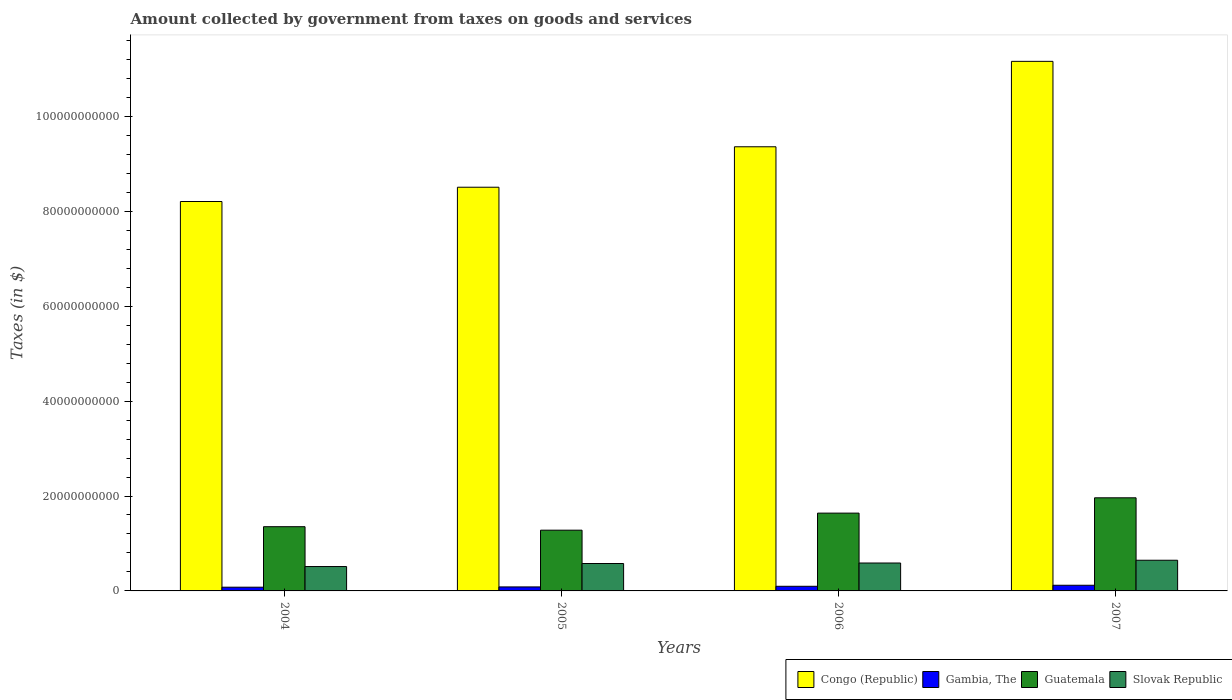How many different coloured bars are there?
Offer a very short reply. 4. Are the number of bars on each tick of the X-axis equal?
Give a very brief answer. Yes. How many bars are there on the 2nd tick from the left?
Your answer should be compact. 4. In how many cases, is the number of bars for a given year not equal to the number of legend labels?
Offer a very short reply. 0. What is the amount collected by government from taxes on goods and services in Slovak Republic in 2005?
Keep it short and to the point. 5.78e+09. Across all years, what is the maximum amount collected by government from taxes on goods and services in Slovak Republic?
Your answer should be very brief. 6.47e+09. Across all years, what is the minimum amount collected by government from taxes on goods and services in Slovak Republic?
Offer a terse response. 5.14e+09. In which year was the amount collected by government from taxes on goods and services in Slovak Republic maximum?
Make the answer very short. 2007. In which year was the amount collected by government from taxes on goods and services in Guatemala minimum?
Keep it short and to the point. 2005. What is the total amount collected by government from taxes on goods and services in Guatemala in the graph?
Provide a succinct answer. 6.24e+1. What is the difference between the amount collected by government from taxes on goods and services in Slovak Republic in 2004 and that in 2005?
Keep it short and to the point. -6.38e+08. What is the difference between the amount collected by government from taxes on goods and services in Guatemala in 2005 and the amount collected by government from taxes on goods and services in Congo (Republic) in 2006?
Ensure brevity in your answer.  -8.08e+1. What is the average amount collected by government from taxes on goods and services in Guatemala per year?
Your response must be concise. 1.56e+1. In the year 2006, what is the difference between the amount collected by government from taxes on goods and services in Guatemala and amount collected by government from taxes on goods and services in Gambia, The?
Make the answer very short. 1.54e+1. What is the ratio of the amount collected by government from taxes on goods and services in Slovak Republic in 2005 to that in 2006?
Make the answer very short. 0.98. Is the difference between the amount collected by government from taxes on goods and services in Guatemala in 2004 and 2006 greater than the difference between the amount collected by government from taxes on goods and services in Gambia, The in 2004 and 2006?
Provide a short and direct response. No. What is the difference between the highest and the second highest amount collected by government from taxes on goods and services in Slovak Republic?
Your answer should be very brief. 5.83e+08. What is the difference between the highest and the lowest amount collected by government from taxes on goods and services in Guatemala?
Make the answer very short. 6.82e+09. What does the 2nd bar from the left in 2006 represents?
Provide a succinct answer. Gambia, The. What does the 1st bar from the right in 2006 represents?
Give a very brief answer. Slovak Republic. Is it the case that in every year, the sum of the amount collected by government from taxes on goods and services in Guatemala and amount collected by government from taxes on goods and services in Congo (Republic) is greater than the amount collected by government from taxes on goods and services in Gambia, The?
Your answer should be very brief. Yes. What is the difference between two consecutive major ticks on the Y-axis?
Keep it short and to the point. 2.00e+1. Does the graph contain any zero values?
Your response must be concise. No. Where does the legend appear in the graph?
Provide a short and direct response. Bottom right. How many legend labels are there?
Your answer should be compact. 4. How are the legend labels stacked?
Make the answer very short. Horizontal. What is the title of the graph?
Give a very brief answer. Amount collected by government from taxes on goods and services. What is the label or title of the Y-axis?
Your response must be concise. Taxes (in $). What is the Taxes (in $) of Congo (Republic) in 2004?
Provide a short and direct response. 8.21e+1. What is the Taxes (in $) of Gambia, The in 2004?
Provide a short and direct response. 7.87e+08. What is the Taxes (in $) in Guatemala in 2004?
Keep it short and to the point. 1.35e+1. What is the Taxes (in $) of Slovak Republic in 2004?
Offer a very short reply. 5.14e+09. What is the Taxes (in $) in Congo (Republic) in 2005?
Your response must be concise. 8.51e+1. What is the Taxes (in $) in Gambia, The in 2005?
Keep it short and to the point. 8.43e+08. What is the Taxes (in $) of Guatemala in 2005?
Your answer should be very brief. 1.28e+1. What is the Taxes (in $) of Slovak Republic in 2005?
Your response must be concise. 5.78e+09. What is the Taxes (in $) in Congo (Republic) in 2006?
Make the answer very short. 9.36e+1. What is the Taxes (in $) of Gambia, The in 2006?
Your response must be concise. 9.76e+08. What is the Taxes (in $) of Guatemala in 2006?
Offer a terse response. 1.64e+1. What is the Taxes (in $) in Slovak Republic in 2006?
Your answer should be compact. 5.88e+09. What is the Taxes (in $) of Congo (Republic) in 2007?
Make the answer very short. 1.12e+11. What is the Taxes (in $) in Gambia, The in 2007?
Give a very brief answer. 1.19e+09. What is the Taxes (in $) of Guatemala in 2007?
Offer a very short reply. 1.96e+1. What is the Taxes (in $) of Slovak Republic in 2007?
Offer a terse response. 6.47e+09. Across all years, what is the maximum Taxes (in $) of Congo (Republic)?
Keep it short and to the point. 1.12e+11. Across all years, what is the maximum Taxes (in $) of Gambia, The?
Your answer should be very brief. 1.19e+09. Across all years, what is the maximum Taxes (in $) of Guatemala?
Offer a terse response. 1.96e+1. Across all years, what is the maximum Taxes (in $) of Slovak Republic?
Provide a short and direct response. 6.47e+09. Across all years, what is the minimum Taxes (in $) in Congo (Republic)?
Ensure brevity in your answer.  8.21e+1. Across all years, what is the minimum Taxes (in $) of Gambia, The?
Give a very brief answer. 7.87e+08. Across all years, what is the minimum Taxes (in $) of Guatemala?
Your answer should be compact. 1.28e+1. Across all years, what is the minimum Taxes (in $) in Slovak Republic?
Make the answer very short. 5.14e+09. What is the total Taxes (in $) of Congo (Republic) in the graph?
Your response must be concise. 3.72e+11. What is the total Taxes (in $) in Gambia, The in the graph?
Provide a short and direct response. 3.80e+09. What is the total Taxes (in $) in Guatemala in the graph?
Provide a short and direct response. 6.24e+1. What is the total Taxes (in $) of Slovak Republic in the graph?
Your answer should be very brief. 2.33e+1. What is the difference between the Taxes (in $) in Congo (Republic) in 2004 and that in 2005?
Offer a terse response. -3.01e+09. What is the difference between the Taxes (in $) in Gambia, The in 2004 and that in 2005?
Your response must be concise. -5.66e+07. What is the difference between the Taxes (in $) of Guatemala in 2004 and that in 2005?
Your answer should be very brief. 7.36e+08. What is the difference between the Taxes (in $) in Slovak Republic in 2004 and that in 2005?
Offer a very short reply. -6.38e+08. What is the difference between the Taxes (in $) in Congo (Republic) in 2004 and that in 2006?
Your answer should be very brief. -1.15e+1. What is the difference between the Taxes (in $) in Gambia, The in 2004 and that in 2006?
Your answer should be very brief. -1.89e+08. What is the difference between the Taxes (in $) of Guatemala in 2004 and that in 2006?
Offer a very short reply. -2.86e+09. What is the difference between the Taxes (in $) of Slovak Republic in 2004 and that in 2006?
Provide a short and direct response. -7.46e+08. What is the difference between the Taxes (in $) of Congo (Republic) in 2004 and that in 2007?
Your answer should be very brief. -2.95e+1. What is the difference between the Taxes (in $) in Gambia, The in 2004 and that in 2007?
Ensure brevity in your answer.  -4.06e+08. What is the difference between the Taxes (in $) in Guatemala in 2004 and that in 2007?
Your response must be concise. -6.09e+09. What is the difference between the Taxes (in $) in Slovak Republic in 2004 and that in 2007?
Your answer should be very brief. -1.33e+09. What is the difference between the Taxes (in $) of Congo (Republic) in 2005 and that in 2006?
Offer a terse response. -8.53e+09. What is the difference between the Taxes (in $) in Gambia, The in 2005 and that in 2006?
Keep it short and to the point. -1.32e+08. What is the difference between the Taxes (in $) of Guatemala in 2005 and that in 2006?
Give a very brief answer. -3.60e+09. What is the difference between the Taxes (in $) in Slovak Republic in 2005 and that in 2006?
Keep it short and to the point. -1.08e+08. What is the difference between the Taxes (in $) in Congo (Republic) in 2005 and that in 2007?
Your answer should be compact. -2.65e+1. What is the difference between the Taxes (in $) of Gambia, The in 2005 and that in 2007?
Offer a terse response. -3.49e+08. What is the difference between the Taxes (in $) of Guatemala in 2005 and that in 2007?
Keep it short and to the point. -6.82e+09. What is the difference between the Taxes (in $) in Slovak Republic in 2005 and that in 2007?
Your answer should be very brief. -6.91e+08. What is the difference between the Taxes (in $) of Congo (Republic) in 2006 and that in 2007?
Offer a very short reply. -1.80e+1. What is the difference between the Taxes (in $) in Gambia, The in 2006 and that in 2007?
Make the answer very short. -2.17e+08. What is the difference between the Taxes (in $) of Guatemala in 2006 and that in 2007?
Keep it short and to the point. -3.23e+09. What is the difference between the Taxes (in $) in Slovak Republic in 2006 and that in 2007?
Provide a succinct answer. -5.83e+08. What is the difference between the Taxes (in $) of Congo (Republic) in 2004 and the Taxes (in $) of Gambia, The in 2005?
Give a very brief answer. 8.12e+1. What is the difference between the Taxes (in $) of Congo (Republic) in 2004 and the Taxes (in $) of Guatemala in 2005?
Make the answer very short. 6.93e+1. What is the difference between the Taxes (in $) in Congo (Republic) in 2004 and the Taxes (in $) in Slovak Republic in 2005?
Provide a short and direct response. 7.63e+1. What is the difference between the Taxes (in $) in Gambia, The in 2004 and the Taxes (in $) in Guatemala in 2005?
Your response must be concise. -1.20e+1. What is the difference between the Taxes (in $) in Gambia, The in 2004 and the Taxes (in $) in Slovak Republic in 2005?
Your response must be concise. -4.99e+09. What is the difference between the Taxes (in $) of Guatemala in 2004 and the Taxes (in $) of Slovak Republic in 2005?
Offer a terse response. 7.76e+09. What is the difference between the Taxes (in $) in Congo (Republic) in 2004 and the Taxes (in $) in Gambia, The in 2006?
Your answer should be very brief. 8.11e+1. What is the difference between the Taxes (in $) of Congo (Republic) in 2004 and the Taxes (in $) of Guatemala in 2006?
Provide a succinct answer. 6.57e+1. What is the difference between the Taxes (in $) in Congo (Republic) in 2004 and the Taxes (in $) in Slovak Republic in 2006?
Your answer should be compact. 7.62e+1. What is the difference between the Taxes (in $) in Gambia, The in 2004 and the Taxes (in $) in Guatemala in 2006?
Your response must be concise. -1.56e+1. What is the difference between the Taxes (in $) of Gambia, The in 2004 and the Taxes (in $) of Slovak Republic in 2006?
Your answer should be compact. -5.10e+09. What is the difference between the Taxes (in $) of Guatemala in 2004 and the Taxes (in $) of Slovak Republic in 2006?
Ensure brevity in your answer.  7.65e+09. What is the difference between the Taxes (in $) of Congo (Republic) in 2004 and the Taxes (in $) of Gambia, The in 2007?
Your answer should be very brief. 8.09e+1. What is the difference between the Taxes (in $) in Congo (Republic) in 2004 and the Taxes (in $) in Guatemala in 2007?
Make the answer very short. 6.24e+1. What is the difference between the Taxes (in $) of Congo (Republic) in 2004 and the Taxes (in $) of Slovak Republic in 2007?
Your answer should be compact. 7.56e+1. What is the difference between the Taxes (in $) in Gambia, The in 2004 and the Taxes (in $) in Guatemala in 2007?
Give a very brief answer. -1.88e+1. What is the difference between the Taxes (in $) in Gambia, The in 2004 and the Taxes (in $) in Slovak Republic in 2007?
Your answer should be compact. -5.68e+09. What is the difference between the Taxes (in $) of Guatemala in 2004 and the Taxes (in $) of Slovak Republic in 2007?
Offer a very short reply. 7.07e+09. What is the difference between the Taxes (in $) of Congo (Republic) in 2005 and the Taxes (in $) of Gambia, The in 2006?
Provide a succinct answer. 8.41e+1. What is the difference between the Taxes (in $) of Congo (Republic) in 2005 and the Taxes (in $) of Guatemala in 2006?
Offer a terse response. 6.87e+1. What is the difference between the Taxes (in $) of Congo (Republic) in 2005 and the Taxes (in $) of Slovak Republic in 2006?
Ensure brevity in your answer.  7.92e+1. What is the difference between the Taxes (in $) of Gambia, The in 2005 and the Taxes (in $) of Guatemala in 2006?
Provide a succinct answer. -1.56e+1. What is the difference between the Taxes (in $) of Gambia, The in 2005 and the Taxes (in $) of Slovak Republic in 2006?
Your answer should be very brief. -5.04e+09. What is the difference between the Taxes (in $) of Guatemala in 2005 and the Taxes (in $) of Slovak Republic in 2006?
Your answer should be compact. 6.92e+09. What is the difference between the Taxes (in $) in Congo (Republic) in 2005 and the Taxes (in $) in Gambia, The in 2007?
Offer a terse response. 8.39e+1. What is the difference between the Taxes (in $) of Congo (Republic) in 2005 and the Taxes (in $) of Guatemala in 2007?
Provide a succinct answer. 6.55e+1. What is the difference between the Taxes (in $) in Congo (Republic) in 2005 and the Taxes (in $) in Slovak Republic in 2007?
Your answer should be very brief. 7.86e+1. What is the difference between the Taxes (in $) in Gambia, The in 2005 and the Taxes (in $) in Guatemala in 2007?
Provide a short and direct response. -1.88e+1. What is the difference between the Taxes (in $) of Gambia, The in 2005 and the Taxes (in $) of Slovak Republic in 2007?
Keep it short and to the point. -5.62e+09. What is the difference between the Taxes (in $) of Guatemala in 2005 and the Taxes (in $) of Slovak Republic in 2007?
Keep it short and to the point. 6.33e+09. What is the difference between the Taxes (in $) of Congo (Republic) in 2006 and the Taxes (in $) of Gambia, The in 2007?
Your answer should be compact. 9.24e+1. What is the difference between the Taxes (in $) in Congo (Republic) in 2006 and the Taxes (in $) in Guatemala in 2007?
Provide a succinct answer. 7.40e+1. What is the difference between the Taxes (in $) in Congo (Republic) in 2006 and the Taxes (in $) in Slovak Republic in 2007?
Provide a succinct answer. 8.71e+1. What is the difference between the Taxes (in $) of Gambia, The in 2006 and the Taxes (in $) of Guatemala in 2007?
Your answer should be compact. -1.86e+1. What is the difference between the Taxes (in $) of Gambia, The in 2006 and the Taxes (in $) of Slovak Republic in 2007?
Provide a succinct answer. -5.49e+09. What is the difference between the Taxes (in $) in Guatemala in 2006 and the Taxes (in $) in Slovak Republic in 2007?
Offer a very short reply. 9.93e+09. What is the average Taxes (in $) of Congo (Republic) per year?
Offer a terse response. 9.31e+1. What is the average Taxes (in $) of Gambia, The per year?
Keep it short and to the point. 9.50e+08. What is the average Taxes (in $) of Guatemala per year?
Keep it short and to the point. 1.56e+1. What is the average Taxes (in $) of Slovak Republic per year?
Make the answer very short. 5.82e+09. In the year 2004, what is the difference between the Taxes (in $) in Congo (Republic) and Taxes (in $) in Gambia, The?
Your answer should be compact. 8.13e+1. In the year 2004, what is the difference between the Taxes (in $) in Congo (Republic) and Taxes (in $) in Guatemala?
Your answer should be very brief. 6.85e+1. In the year 2004, what is the difference between the Taxes (in $) in Congo (Republic) and Taxes (in $) in Slovak Republic?
Offer a terse response. 7.69e+1. In the year 2004, what is the difference between the Taxes (in $) of Gambia, The and Taxes (in $) of Guatemala?
Provide a succinct answer. -1.27e+1. In the year 2004, what is the difference between the Taxes (in $) in Gambia, The and Taxes (in $) in Slovak Republic?
Your response must be concise. -4.35e+09. In the year 2004, what is the difference between the Taxes (in $) in Guatemala and Taxes (in $) in Slovak Republic?
Provide a short and direct response. 8.40e+09. In the year 2005, what is the difference between the Taxes (in $) of Congo (Republic) and Taxes (in $) of Gambia, The?
Provide a short and direct response. 8.42e+1. In the year 2005, what is the difference between the Taxes (in $) in Congo (Republic) and Taxes (in $) in Guatemala?
Ensure brevity in your answer.  7.23e+1. In the year 2005, what is the difference between the Taxes (in $) of Congo (Republic) and Taxes (in $) of Slovak Republic?
Ensure brevity in your answer.  7.93e+1. In the year 2005, what is the difference between the Taxes (in $) of Gambia, The and Taxes (in $) of Guatemala?
Ensure brevity in your answer.  -1.20e+1. In the year 2005, what is the difference between the Taxes (in $) of Gambia, The and Taxes (in $) of Slovak Republic?
Keep it short and to the point. -4.93e+09. In the year 2005, what is the difference between the Taxes (in $) of Guatemala and Taxes (in $) of Slovak Republic?
Give a very brief answer. 7.02e+09. In the year 2006, what is the difference between the Taxes (in $) of Congo (Republic) and Taxes (in $) of Gambia, The?
Offer a very short reply. 9.26e+1. In the year 2006, what is the difference between the Taxes (in $) of Congo (Republic) and Taxes (in $) of Guatemala?
Provide a succinct answer. 7.72e+1. In the year 2006, what is the difference between the Taxes (in $) of Congo (Republic) and Taxes (in $) of Slovak Republic?
Your answer should be very brief. 8.77e+1. In the year 2006, what is the difference between the Taxes (in $) in Gambia, The and Taxes (in $) in Guatemala?
Provide a succinct answer. -1.54e+1. In the year 2006, what is the difference between the Taxes (in $) of Gambia, The and Taxes (in $) of Slovak Republic?
Keep it short and to the point. -4.91e+09. In the year 2006, what is the difference between the Taxes (in $) of Guatemala and Taxes (in $) of Slovak Republic?
Your response must be concise. 1.05e+1. In the year 2007, what is the difference between the Taxes (in $) of Congo (Republic) and Taxes (in $) of Gambia, The?
Ensure brevity in your answer.  1.10e+11. In the year 2007, what is the difference between the Taxes (in $) in Congo (Republic) and Taxes (in $) in Guatemala?
Your response must be concise. 9.20e+1. In the year 2007, what is the difference between the Taxes (in $) of Congo (Republic) and Taxes (in $) of Slovak Republic?
Provide a short and direct response. 1.05e+11. In the year 2007, what is the difference between the Taxes (in $) in Gambia, The and Taxes (in $) in Guatemala?
Ensure brevity in your answer.  -1.84e+1. In the year 2007, what is the difference between the Taxes (in $) in Gambia, The and Taxes (in $) in Slovak Republic?
Your response must be concise. -5.27e+09. In the year 2007, what is the difference between the Taxes (in $) in Guatemala and Taxes (in $) in Slovak Republic?
Your answer should be compact. 1.32e+1. What is the ratio of the Taxes (in $) in Congo (Republic) in 2004 to that in 2005?
Offer a very short reply. 0.96. What is the ratio of the Taxes (in $) of Gambia, The in 2004 to that in 2005?
Your answer should be very brief. 0.93. What is the ratio of the Taxes (in $) of Guatemala in 2004 to that in 2005?
Your answer should be very brief. 1.06. What is the ratio of the Taxes (in $) of Slovak Republic in 2004 to that in 2005?
Give a very brief answer. 0.89. What is the ratio of the Taxes (in $) of Congo (Republic) in 2004 to that in 2006?
Your answer should be very brief. 0.88. What is the ratio of the Taxes (in $) of Gambia, The in 2004 to that in 2006?
Ensure brevity in your answer.  0.81. What is the ratio of the Taxes (in $) in Guatemala in 2004 to that in 2006?
Give a very brief answer. 0.83. What is the ratio of the Taxes (in $) of Slovak Republic in 2004 to that in 2006?
Offer a terse response. 0.87. What is the ratio of the Taxes (in $) in Congo (Republic) in 2004 to that in 2007?
Your answer should be compact. 0.74. What is the ratio of the Taxes (in $) in Gambia, The in 2004 to that in 2007?
Provide a succinct answer. 0.66. What is the ratio of the Taxes (in $) in Guatemala in 2004 to that in 2007?
Make the answer very short. 0.69. What is the ratio of the Taxes (in $) of Slovak Republic in 2004 to that in 2007?
Ensure brevity in your answer.  0.79. What is the ratio of the Taxes (in $) of Congo (Republic) in 2005 to that in 2006?
Offer a very short reply. 0.91. What is the ratio of the Taxes (in $) of Gambia, The in 2005 to that in 2006?
Offer a very short reply. 0.86. What is the ratio of the Taxes (in $) of Guatemala in 2005 to that in 2006?
Provide a short and direct response. 0.78. What is the ratio of the Taxes (in $) of Slovak Republic in 2005 to that in 2006?
Your answer should be very brief. 0.98. What is the ratio of the Taxes (in $) of Congo (Republic) in 2005 to that in 2007?
Keep it short and to the point. 0.76. What is the ratio of the Taxes (in $) of Gambia, The in 2005 to that in 2007?
Make the answer very short. 0.71. What is the ratio of the Taxes (in $) in Guatemala in 2005 to that in 2007?
Make the answer very short. 0.65. What is the ratio of the Taxes (in $) in Slovak Republic in 2005 to that in 2007?
Offer a terse response. 0.89. What is the ratio of the Taxes (in $) of Congo (Republic) in 2006 to that in 2007?
Offer a very short reply. 0.84. What is the ratio of the Taxes (in $) of Gambia, The in 2006 to that in 2007?
Provide a succinct answer. 0.82. What is the ratio of the Taxes (in $) of Guatemala in 2006 to that in 2007?
Ensure brevity in your answer.  0.84. What is the ratio of the Taxes (in $) in Slovak Republic in 2006 to that in 2007?
Offer a very short reply. 0.91. What is the difference between the highest and the second highest Taxes (in $) of Congo (Republic)?
Provide a short and direct response. 1.80e+1. What is the difference between the highest and the second highest Taxes (in $) of Gambia, The?
Offer a very short reply. 2.17e+08. What is the difference between the highest and the second highest Taxes (in $) of Guatemala?
Your answer should be very brief. 3.23e+09. What is the difference between the highest and the second highest Taxes (in $) of Slovak Republic?
Give a very brief answer. 5.83e+08. What is the difference between the highest and the lowest Taxes (in $) of Congo (Republic)?
Give a very brief answer. 2.95e+1. What is the difference between the highest and the lowest Taxes (in $) in Gambia, The?
Ensure brevity in your answer.  4.06e+08. What is the difference between the highest and the lowest Taxes (in $) in Guatemala?
Your response must be concise. 6.82e+09. What is the difference between the highest and the lowest Taxes (in $) in Slovak Republic?
Give a very brief answer. 1.33e+09. 